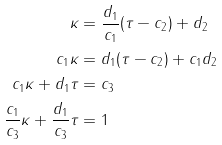Convert formula to latex. <formula><loc_0><loc_0><loc_500><loc_500>\kappa & = \frac { d _ { 1 } } { c _ { 1 } } ( \tau - c _ { 2 } ) + d _ { 2 } \\ c _ { 1 } \kappa & = d _ { 1 } ( \tau - c _ { 2 } ) + c _ { 1 } d _ { 2 } \\ c _ { 1 } \kappa + d _ { 1 } \tau & = c _ { 3 } \\ \frac { c _ { 1 } } { c _ { 3 } } \kappa + \frac { d _ { 1 } } { c _ { 3 } } \tau & = 1</formula> 